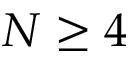<formula> <loc_0><loc_0><loc_500><loc_500>N \geq 4</formula> 